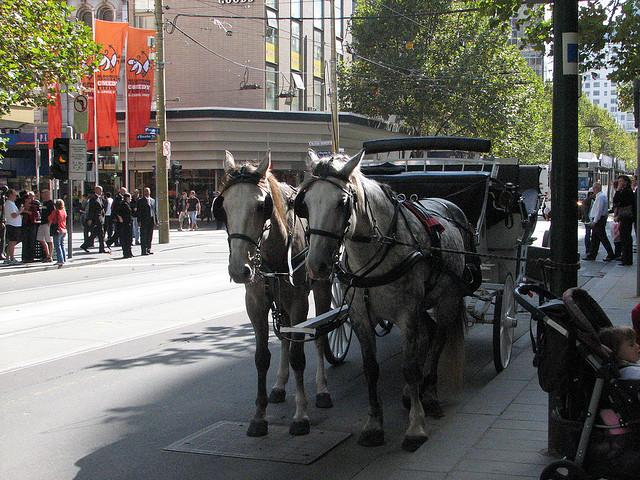What turn is forbidden? Please explain your reasoning. left turn. A left turn is forbidden on this highway. 